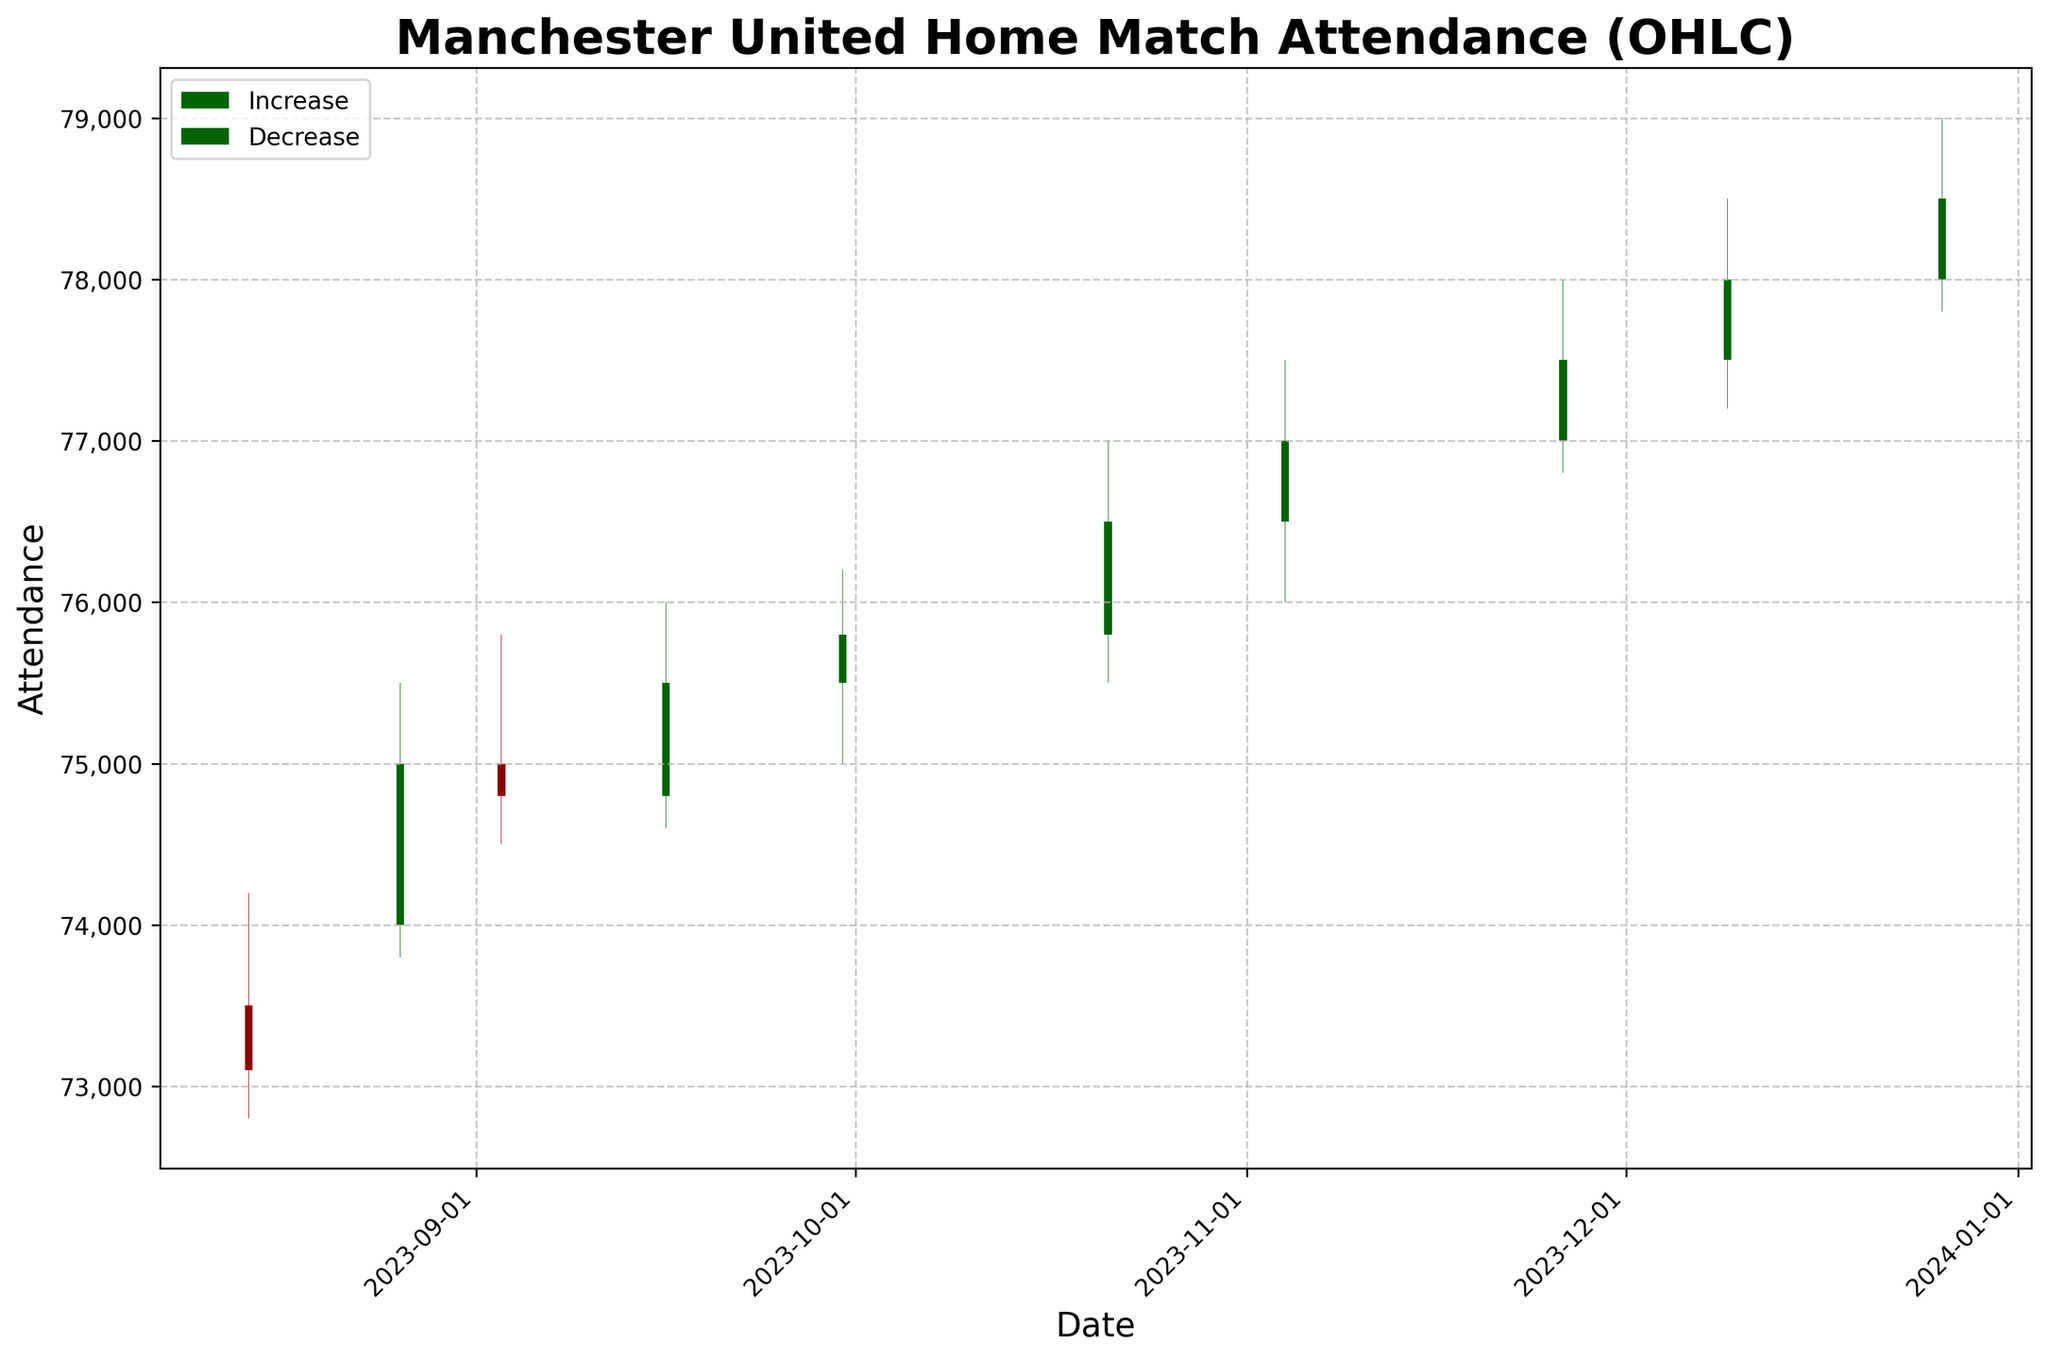What's the highest attendance recorded in a match? The highest attendance is represented by the highest 'High' value in the figure, which is 79,000 on December 26, 2023.
Answer: 79,000 How many times did the attendance decrease compared to the previous closing attendance? To find out the number of decreases, count the number of red bars in the figure, which represent matches where the closing attendance was less than the opening attendance.
Answer: 2 Which match had the lowest opening attendance? The match with the lowest opening attendance can be identified by the lowest 'Open' value in the figure, which occurred on August 14, 2023, with an opening attendance of 73,500.
Answer: 73,500 What's the average closing attendance for the matches? The average closing attendance is calculated by summing all 'Close' values and dividing by the number of matches (73100 + 75000 + 74800 + 75500 + 75800 + 76500 + 77000 + 77500 + 78000 + 78500) / 10 = 76100.
Answer: 76,100 Which match experienced the largest single-day increase in attendance? To determine the largest single-day increase, find the match with the largest difference between 'Close' and 'Open' where 'Close' > 'Open'. The match on August 26, 2023, had an increase of 75000 - 74000 = 1000.
Answer: August 26, 2023 What's the total number of matches shown in the figure? The total number of matches is equal to the number of data points, which can be counted from the x-axis labels or the bars. There are 10 matches shown.
Answer: 10 Did the closing attendance always increase as the season progressed? Examine the trend line of the closing attendance from match to match. Despite some fluctuations, the closing attendance generally increases but does not always strictly increase every time (e.g., September 3, 2023, to September 16, 2023, shows a decline).
Answer: No What was the attendance range (difference between the highest and lowest attendance) on November 26, 2023? The attendance range for November 26, 2023, is determined by subtracting the 'Low' value from the 'High' value: 78000 - 76800 = 1200.
Answer: 1,200 Which month had the highest overall attendance? By observing the figure and summing the closing attendances for each month: August (1,14800 + 14800 = 14800), September (74800 + 75500 + 78000 = 76000), October (76500), November (77000 + 77500 = 154500), December (78000 + 78500 = 156500), the highest total is for December.
Answer: December What's the median closing attendance? To find the median, list all closing attendances in ascending order and find the middle value. For 10 data points: (73100, 74800, 75000, 75500, 75800, 76500, 77000, 77500, 78000, 78500), the median is the average of the 5th and 6th values: (75800 + 76500) / 2 = 76150.
Answer: 76,150 